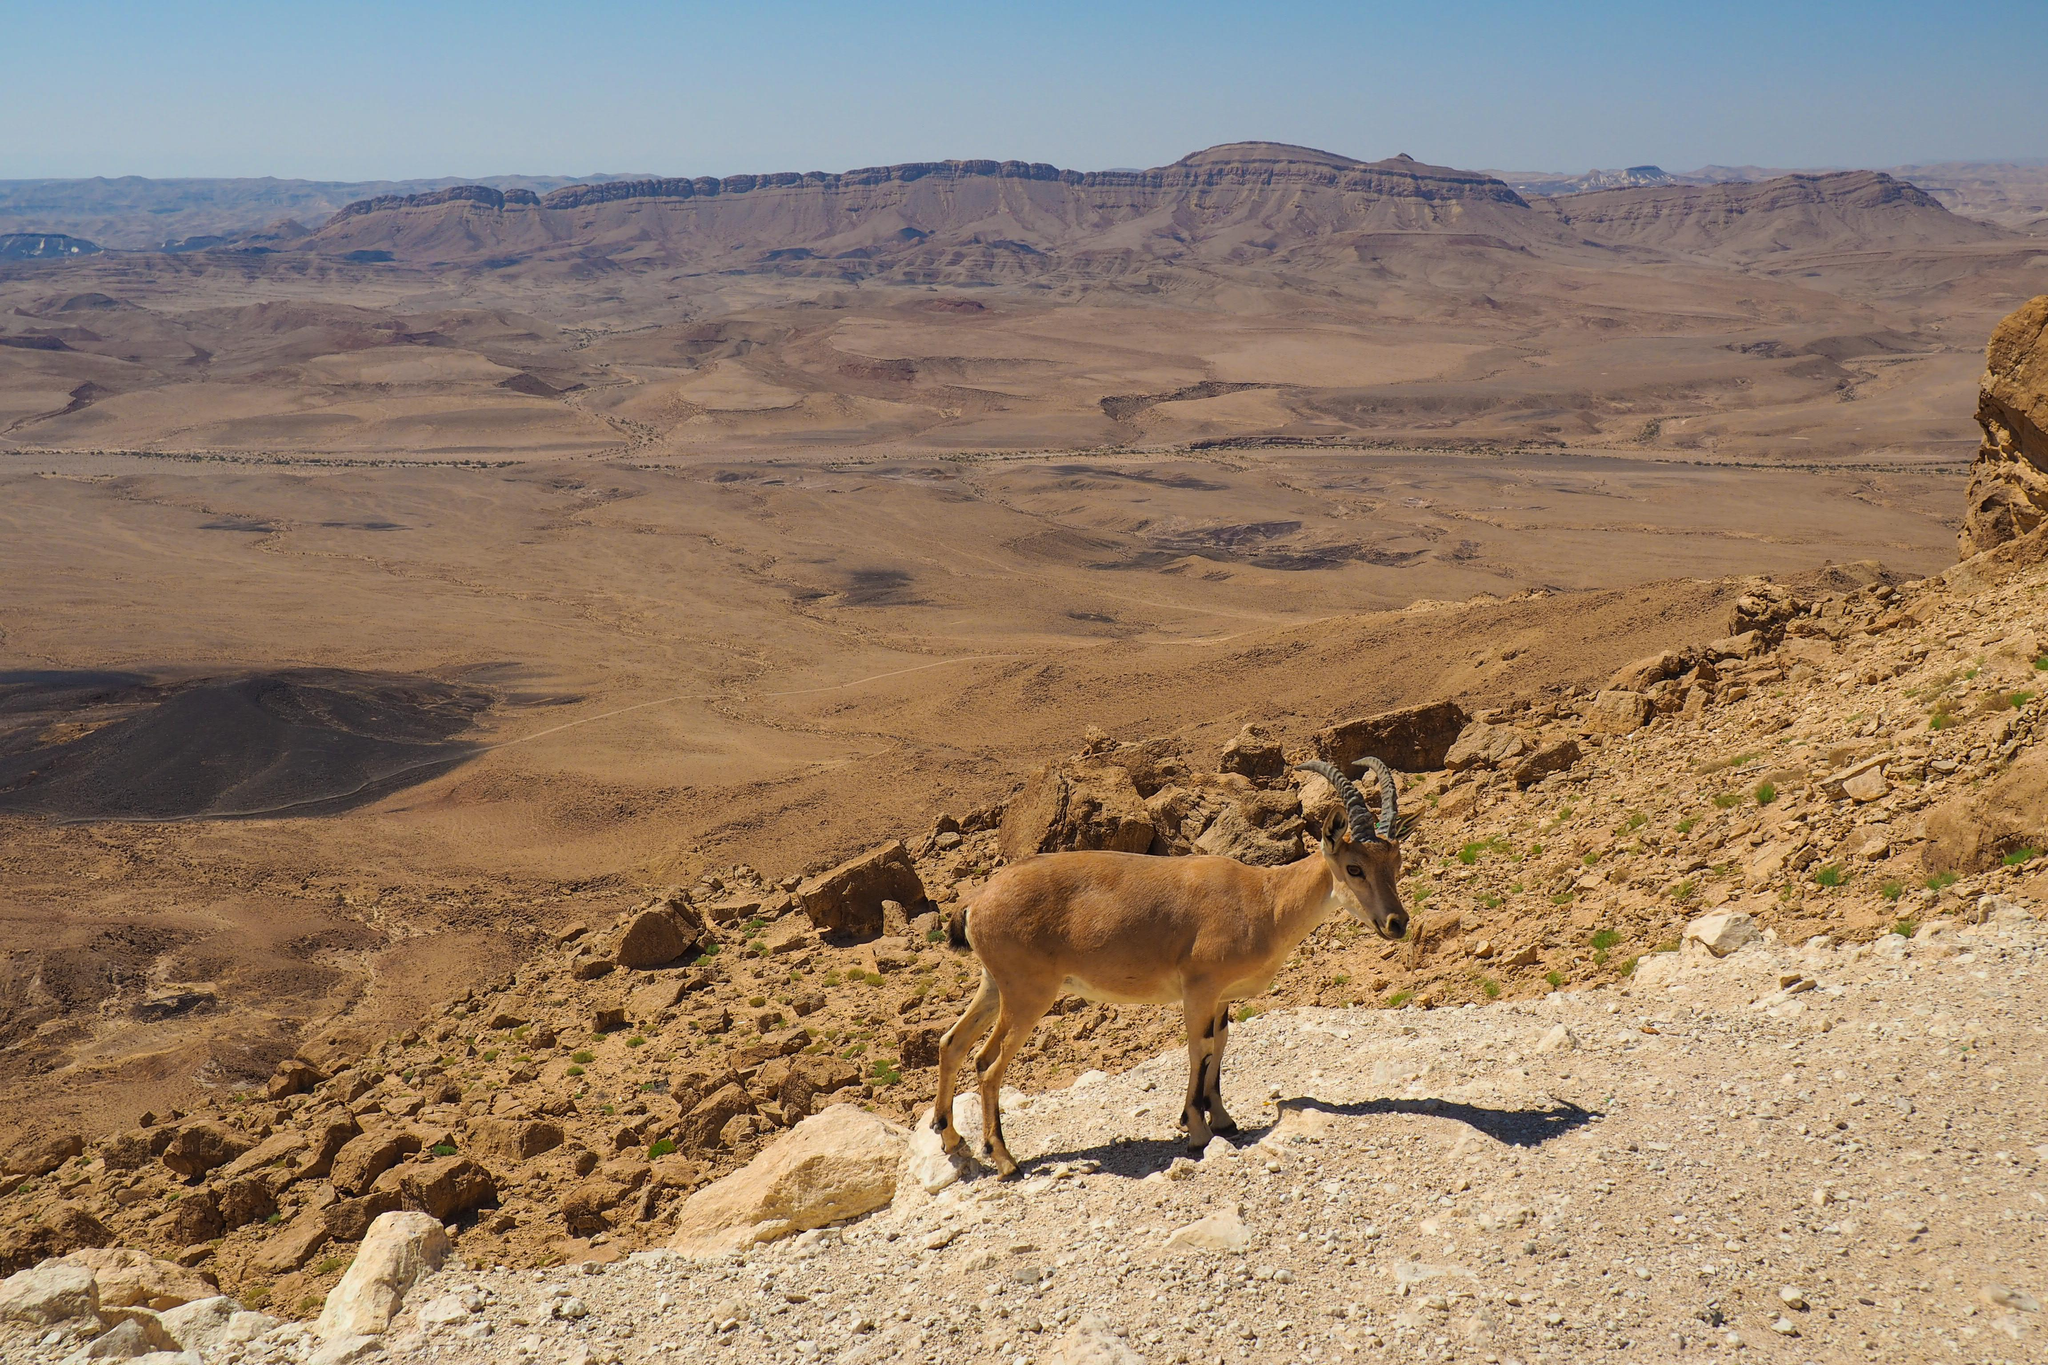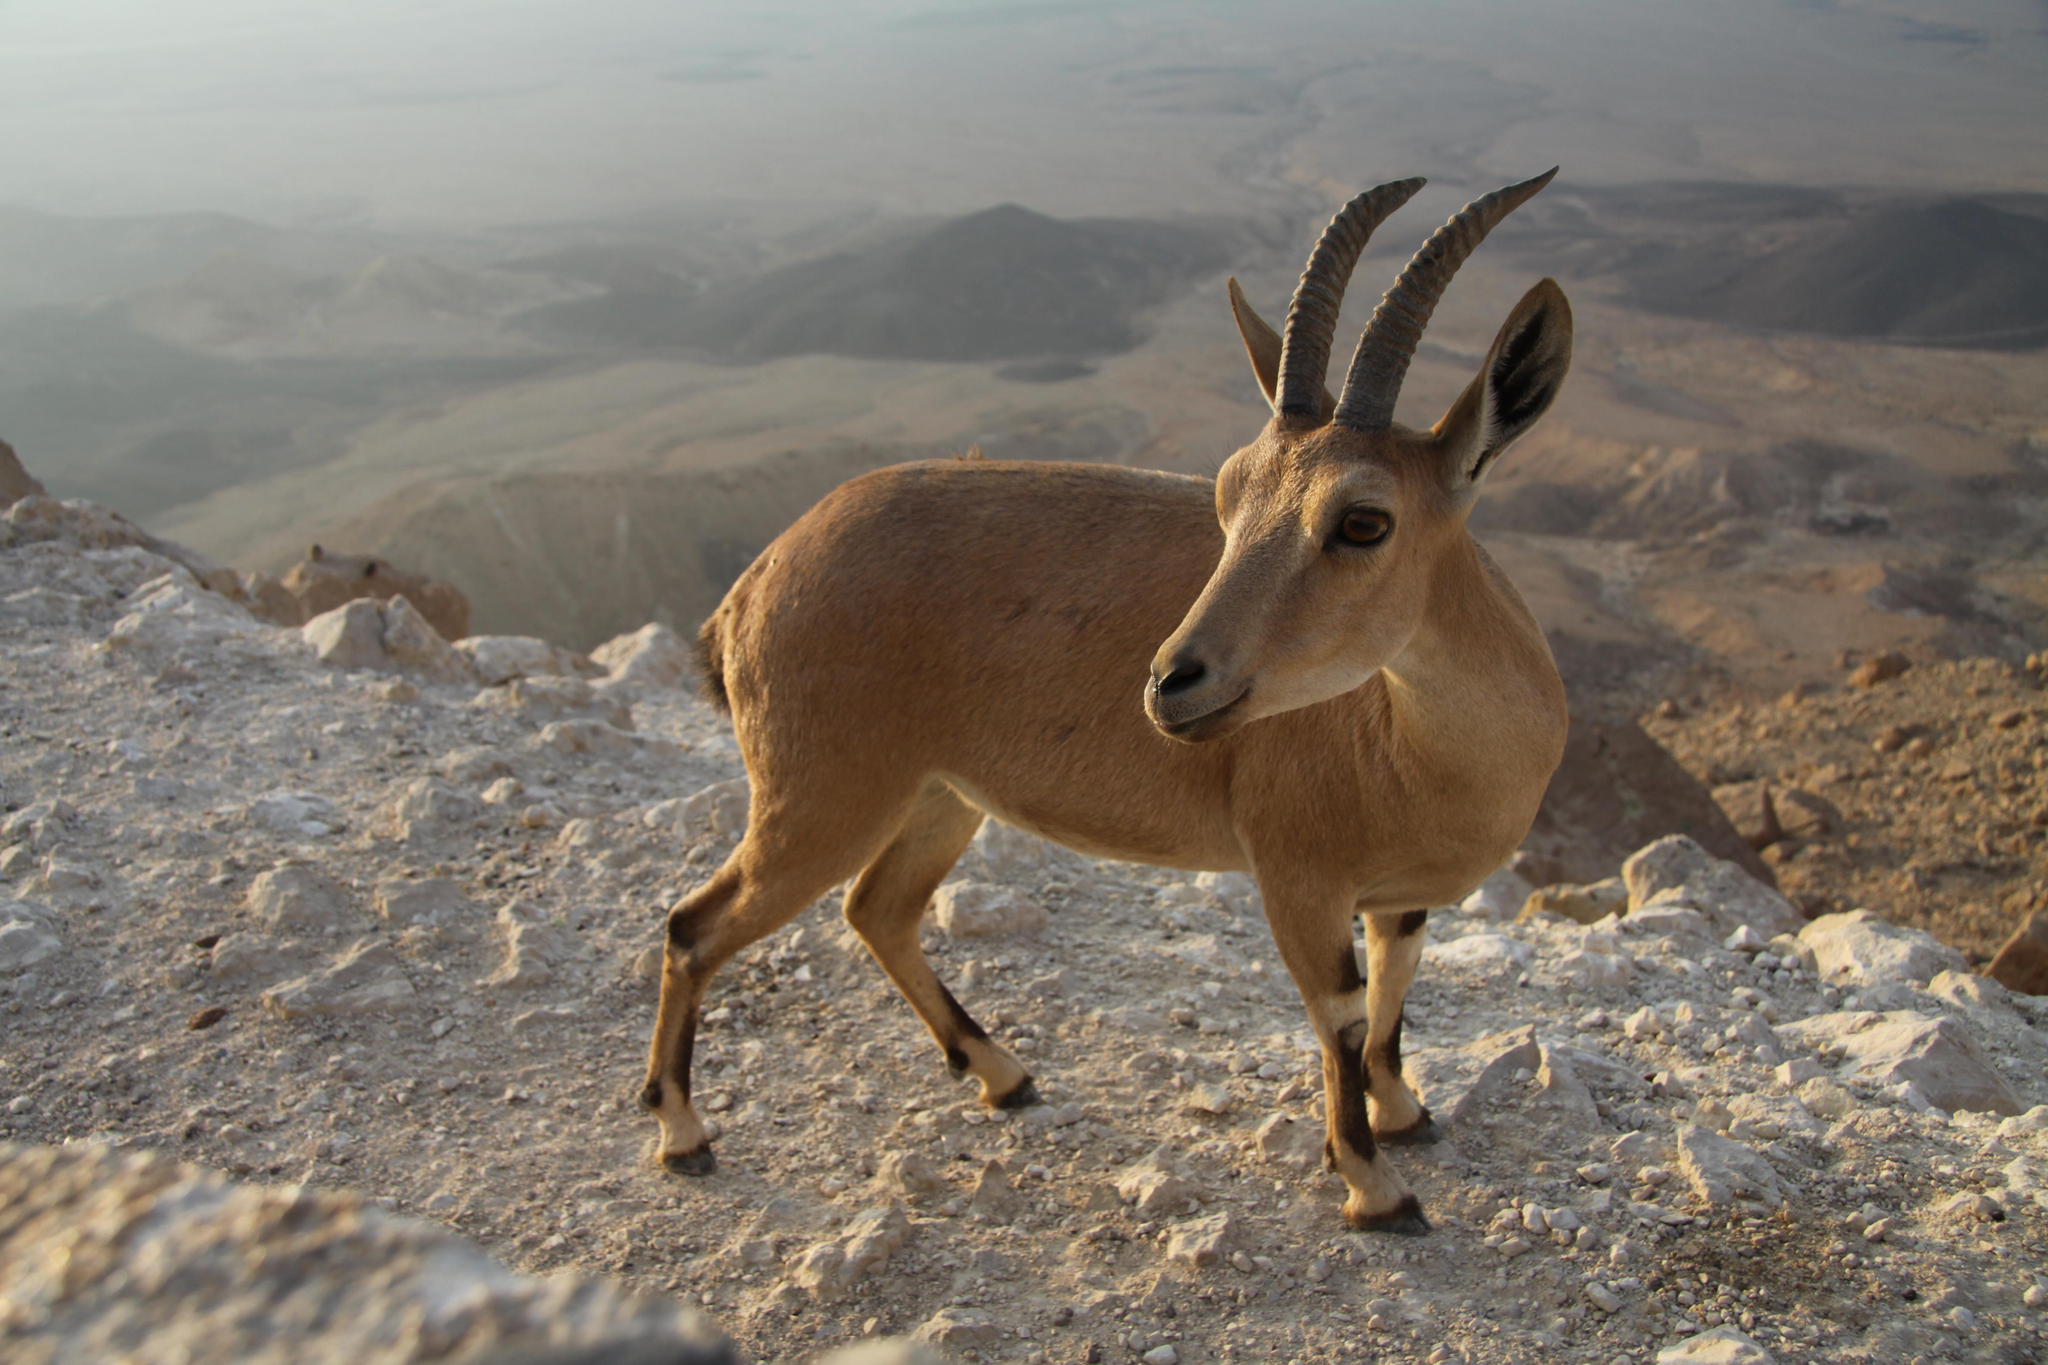The first image is the image on the left, the second image is the image on the right. Considering the images on both sides, is "A single animal is standing on a rocky area in the image on the left." valid? Answer yes or no. Yes. The first image is the image on the left, the second image is the image on the right. Examine the images to the left and right. Is the description "An image includes a hooved animal standing on the edge of a low man-made wall." accurate? Answer yes or no. No. 